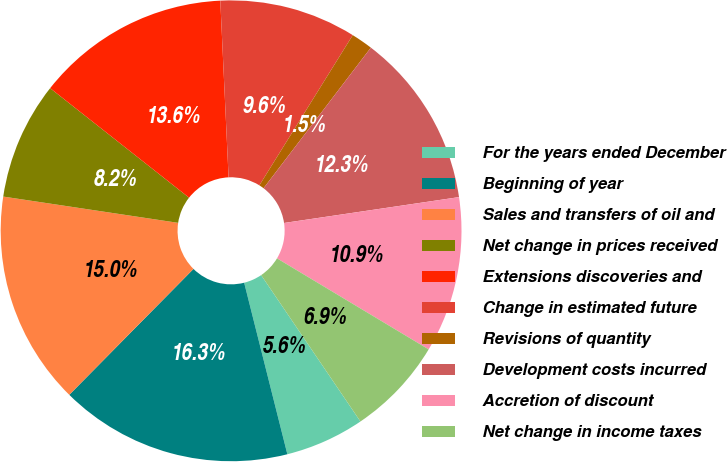<chart> <loc_0><loc_0><loc_500><loc_500><pie_chart><fcel>For the years ended December<fcel>Beginning of year<fcel>Sales and transfers of oil and<fcel>Net change in prices received<fcel>Extensions discoveries and<fcel>Change in estimated future<fcel>Revisions of quantity<fcel>Development costs incurred<fcel>Accretion of discount<fcel>Net change in income taxes<nl><fcel>5.56%<fcel>16.32%<fcel>14.98%<fcel>8.25%<fcel>13.63%<fcel>9.6%<fcel>1.52%<fcel>12.29%<fcel>10.94%<fcel>6.91%<nl></chart> 